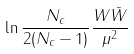<formula> <loc_0><loc_0><loc_500><loc_500>\ln \frac { N _ { c } } { 2 ( N _ { c } - 1 ) } \frac { W \bar { W } } { \mu ^ { 2 } }</formula> 